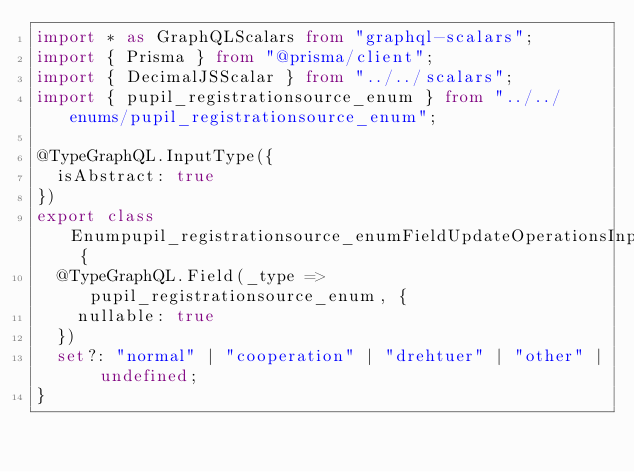<code> <loc_0><loc_0><loc_500><loc_500><_TypeScript_>import * as GraphQLScalars from "graphql-scalars";
import { Prisma } from "@prisma/client";
import { DecimalJSScalar } from "../../scalars";
import { pupil_registrationsource_enum } from "../../enums/pupil_registrationsource_enum";

@TypeGraphQL.InputType({
  isAbstract: true
})
export class Enumpupil_registrationsource_enumFieldUpdateOperationsInput {
  @TypeGraphQL.Field(_type => pupil_registrationsource_enum, {
    nullable: true
  })
  set?: "normal" | "cooperation" | "drehtuer" | "other" | undefined;
}
</code> 